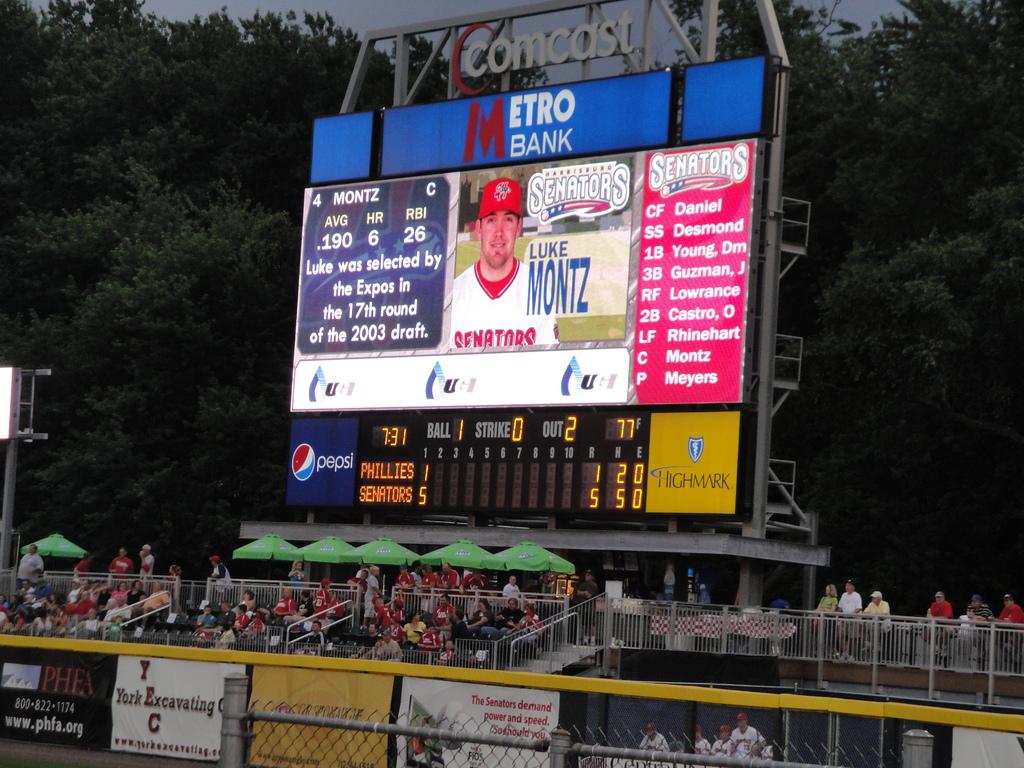What bank is on the sign?
Give a very brief answer. Metro bank. What baseball team is that?
Keep it short and to the point. Senators. 